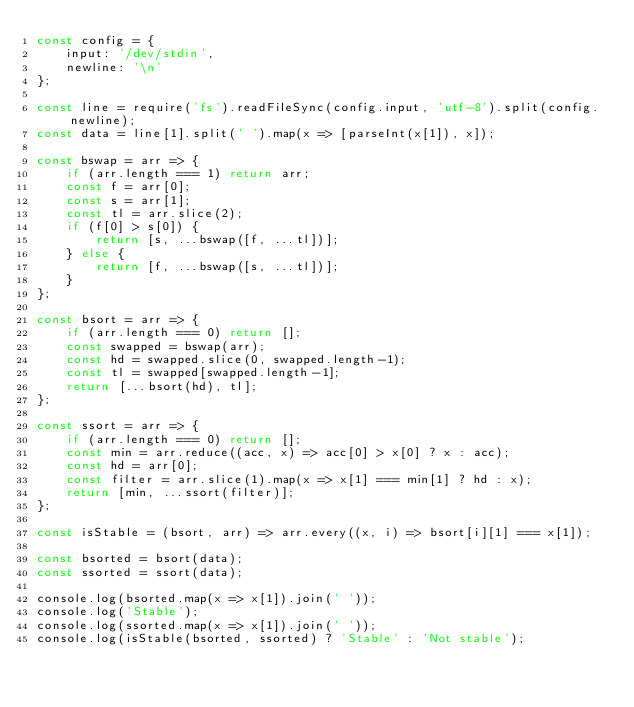Convert code to text. <code><loc_0><loc_0><loc_500><loc_500><_JavaScript_>const config = {
    input: '/dev/stdin',
    newline: '\n'
};

const line = require('fs').readFileSync(config.input, 'utf-8').split(config.newline);
const data = line[1].split(' ').map(x => [parseInt(x[1]), x]);

const bswap = arr => {
    if (arr.length === 1) return arr;
    const f = arr[0];
    const s = arr[1];
    const tl = arr.slice(2);
    if (f[0] > s[0]) {
        return [s, ...bswap([f, ...tl])];
    } else {
        return [f, ...bswap([s, ...tl])];
    }
};

const bsort = arr => {
    if (arr.length === 0) return [];
    const swapped = bswap(arr);
    const hd = swapped.slice(0, swapped.length-1);
    const tl = swapped[swapped.length-1];
    return [...bsort(hd), tl];
};

const ssort = arr => {
    if (arr.length === 0) return [];
    const min = arr.reduce((acc, x) => acc[0] > x[0] ? x : acc);
    const hd = arr[0];
    const filter = arr.slice(1).map(x => x[1] === min[1] ? hd : x);
    return [min, ...ssort(filter)];
};

const isStable = (bsort, arr) => arr.every((x, i) => bsort[i][1] === x[1]);

const bsorted = bsort(data);
const ssorted = ssort(data);

console.log(bsorted.map(x => x[1]).join(' '));
console.log('Stable');
console.log(ssorted.map(x => x[1]).join(' '));
console.log(isStable(bsorted, ssorted) ? 'Stable' : 'Not stable');

</code> 